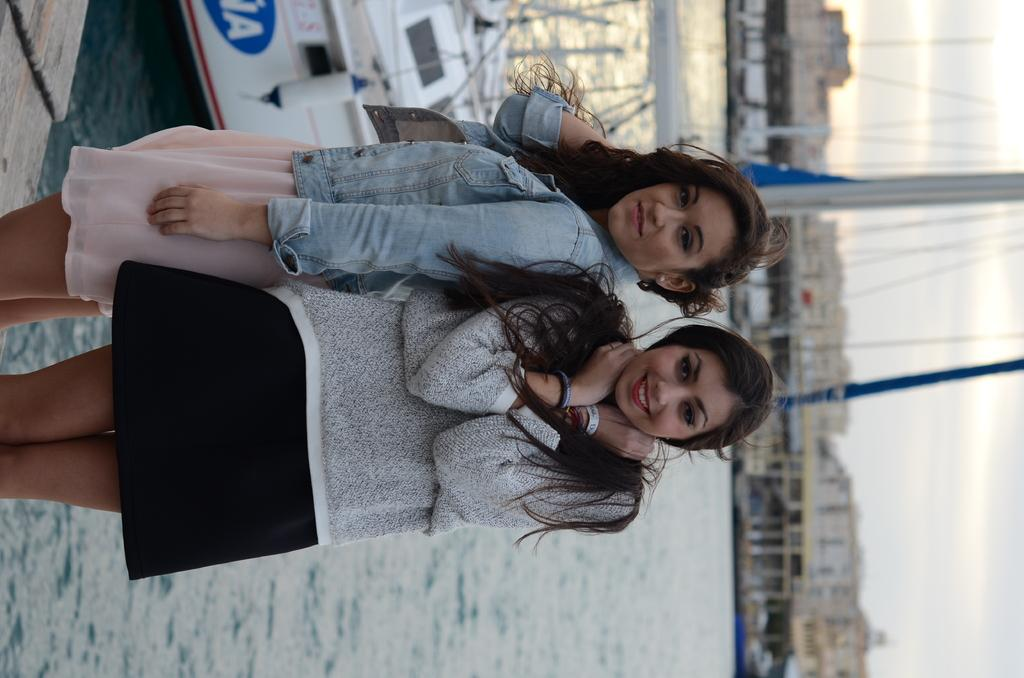How many women are in the image? There are two women standing in the image. What can be seen in the background of the image? There is a ship on the water, a pole, buildings, objects, and clouds in the sky in the background. What type of business is the coach conducting in the image? There is no coach or business-related activity present in the image. 